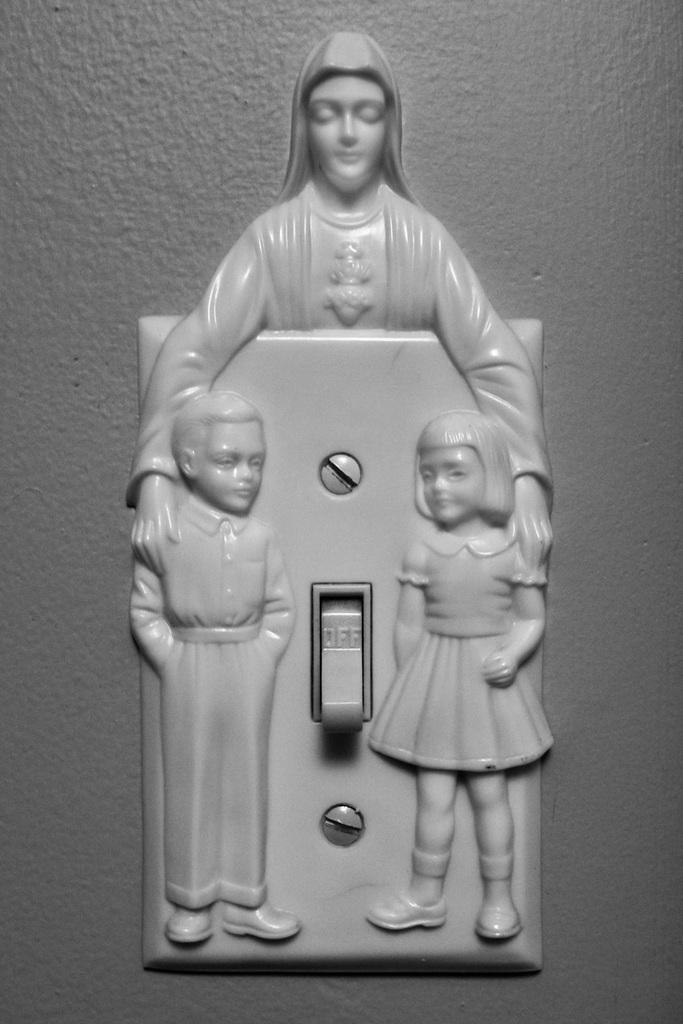What is the main subject of the image? The main subject of the image is a switchboard. What feature of the switchboard can be observed in the image? The switchboard has sculptures. Where is the switchboard located in the image? The switchboard is placed on a wall. What type of camp can be seen in the image? There is no camp present in the image; it features a switchboard with sculptures on a wall. What is the home of the sculptures on the switchboard in the image? The image does not provide information about the home of the sculptures; it only shows them on the switchboard. 